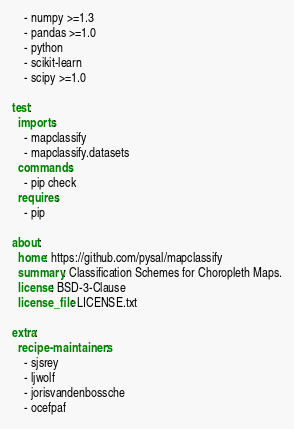<code> <loc_0><loc_0><loc_500><loc_500><_YAML_>    - numpy >=1.3
    - pandas >=1.0
    - python
    - scikit-learn
    - scipy >=1.0

test:
  imports:
    - mapclassify
    - mapclassify.datasets
  commands:
    - pip check
  requires:
    - pip

about:
  home: https://github.com/pysal/mapclassify
  summary: Classification Schemes for Choropleth Maps.
  license: BSD-3-Clause
  license_file: LICENSE.txt

extra:
  recipe-maintainers:
    - sjsrey
    - ljwolf
    - jorisvandenbossche
    - ocefpaf
</code> 